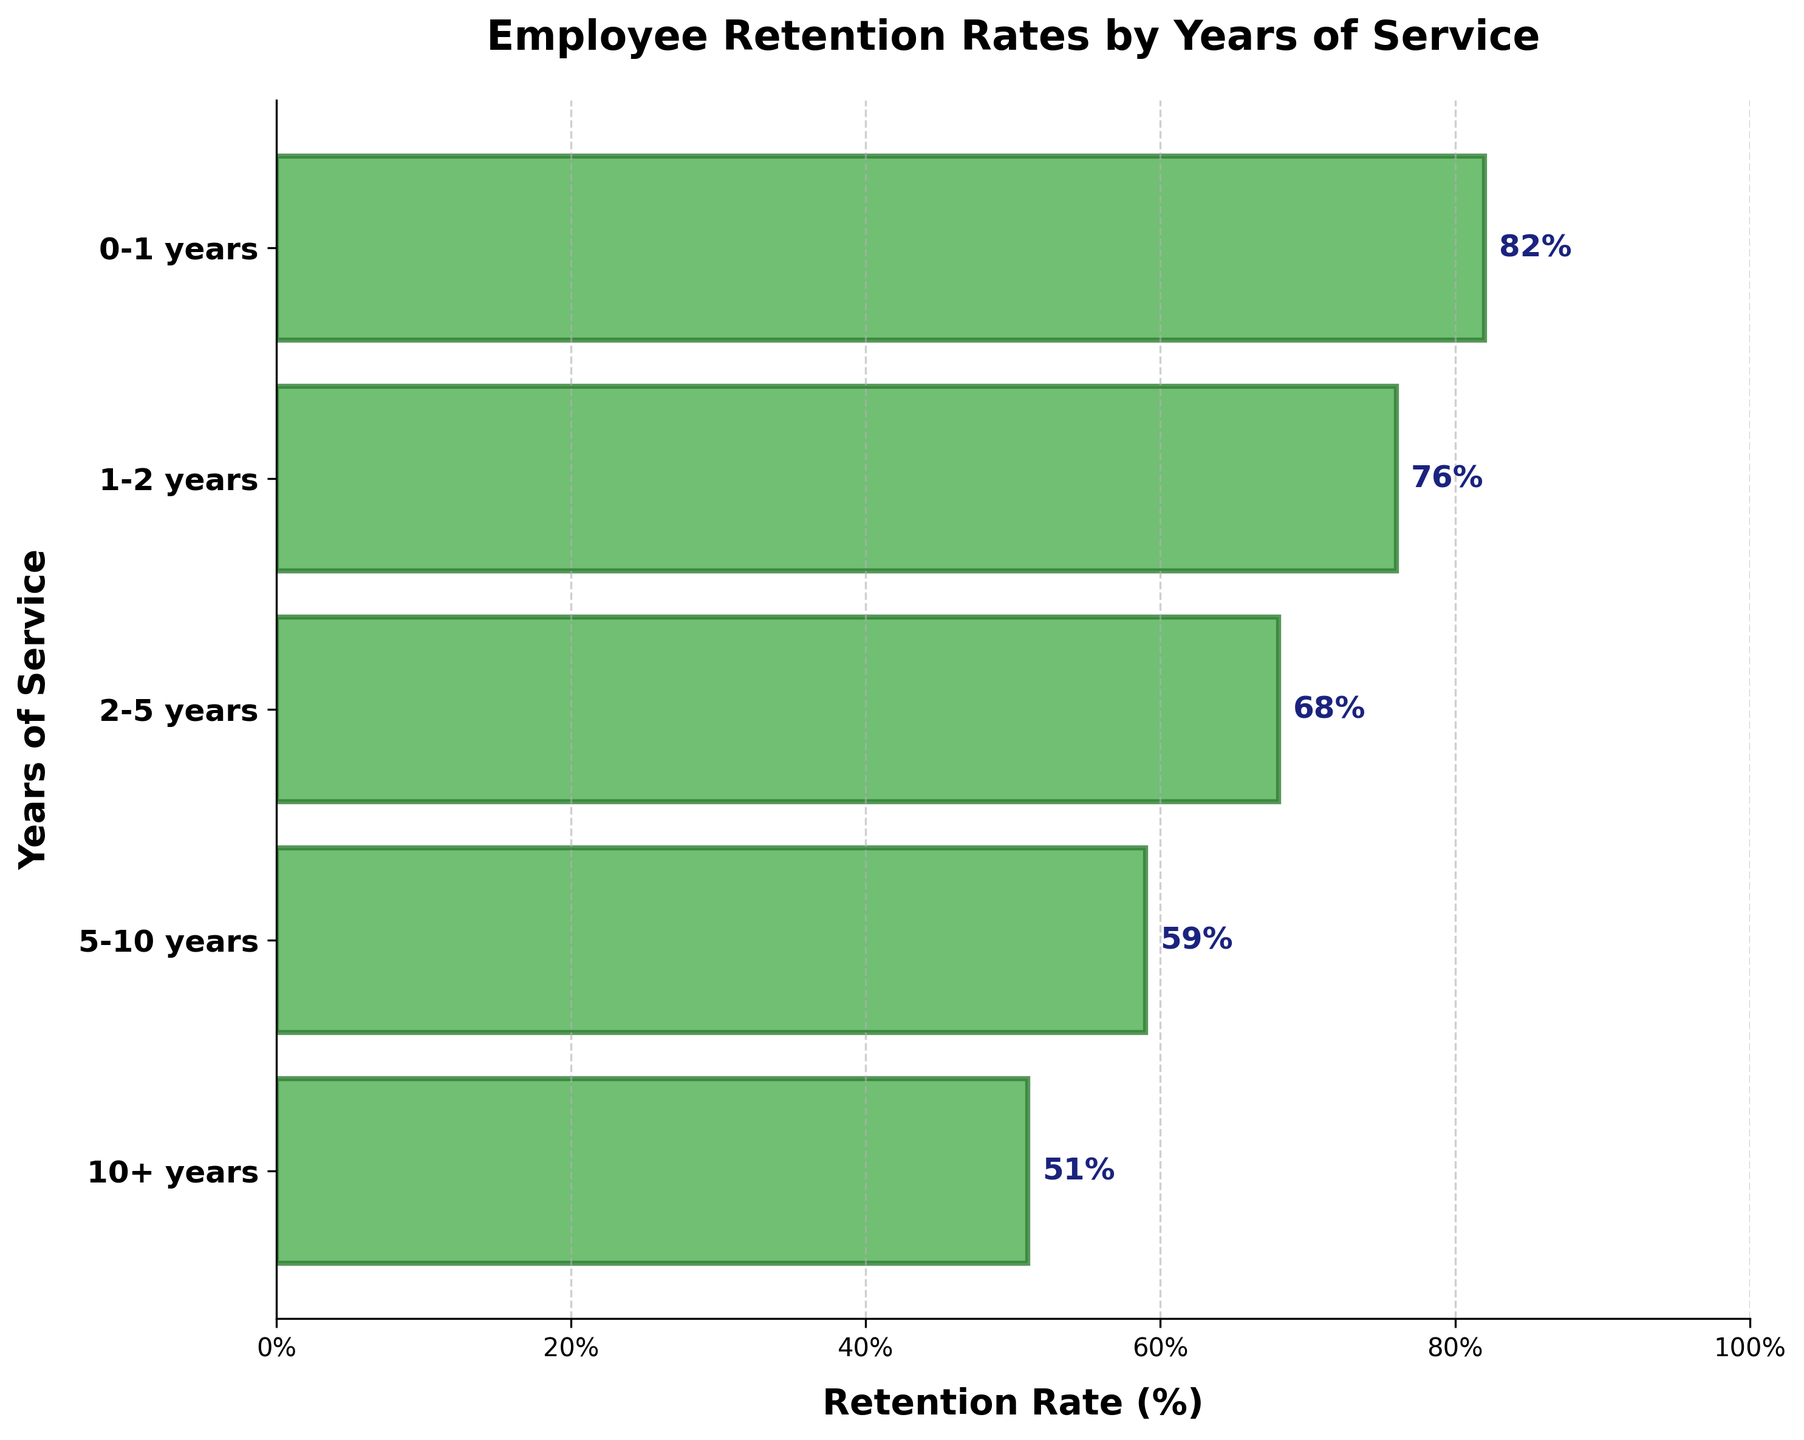What's the retention rate for employees with 1-2 years of service? The figure shows the retention rates on a horizontal bar chart by years of service. Locate the bar corresponding to "1-2 years" and read the retention rate value.
Answer: 76% What is the overall trend in retention rates as years of service increase? Observing the lengths of the horizontal bars from top to bottom, we see that the bars decrease in length, showing that retention rates decrease as years of service increase.
Answer: Decreasing How many years of service lead to the lowest retention rate? Look at the labels on the y-axis to see the years of service, then find the shortest bar, which indicates the lowest retention rate.
Answer: 10+ years Which years of service group has a retention rate closest to 60%? Observe the lengths of the horizontal bars and identify the one closest to 60% on the x-axis.
Answer: 5-10 years What's the difference in retention rate between the 0-1 years and 10+ years groups? Find the retention rates for 0-1 years (82%) and 10+ years (51%), then subtract the latter from the former.
Answer: 31% Are the retention rates for 2-5 years and 5-10 years closer than between other consecutive groups? Compare the differences between consecutive groups: 0-1 years to 1-2 years (82%-76%=6%), 1-2 years to 2-5 years (76%-68%=8%), 2-5 years to 5-10 years (68%-59%=9%), and 5-10 years to 10+ years (59%-51%=8%). The smaller the difference, the closer the values are.
Answer: No What's the average retention rate across all the groups? Sum the retention rates for all groups (82% + 76% + 68% + 59% + 51% = 336%) and divide by the number of groups (5).
Answer: 67.2% Which group has a retention rate below 60%? Look at the lengths of the horizontal bars to see which one falls below the 60% line on the x-axis.
Answer: 10+ years What's the median retention rate of all the groups? List all the retention rates in order (51%, 59%, 68%, 76%, 82%) and find the middle value.
Answer: 68% How much lower is the retention rate for 5-10 years compared to 0-1 years? Find the retention rates for 5-10 years (59%) and 0-1 years (82%), then subtract the former from the latter.
Answer: 23% 